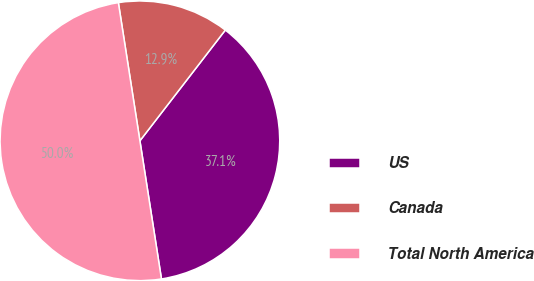Convert chart. <chart><loc_0><loc_0><loc_500><loc_500><pie_chart><fcel>US<fcel>Canada<fcel>Total North America<nl><fcel>37.08%<fcel>12.92%<fcel>50.0%<nl></chart> 